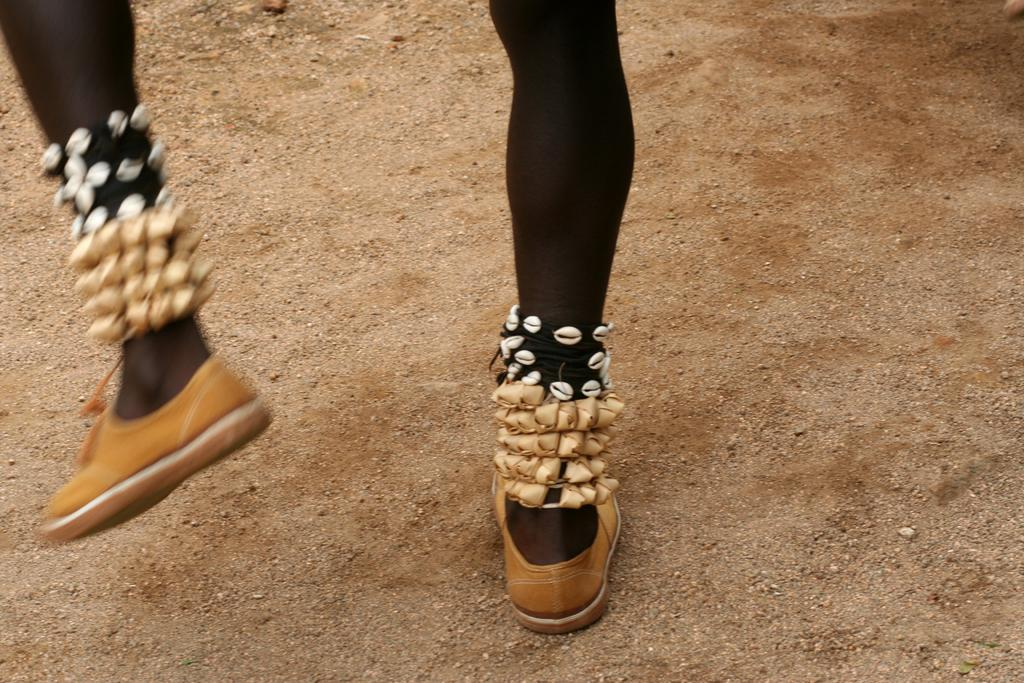What body parts are visible in the image? There are human legs with shoes in the image. Can you describe any other objects or features in the image? There are some unspecified things in the image. What is visible at the bottom of the image? There is a ground visible at the bottom of the image. How many girls with tails are visible in the image? There are no girls or tails visible in the image; only human legs with shoes and unspecified things are present. 